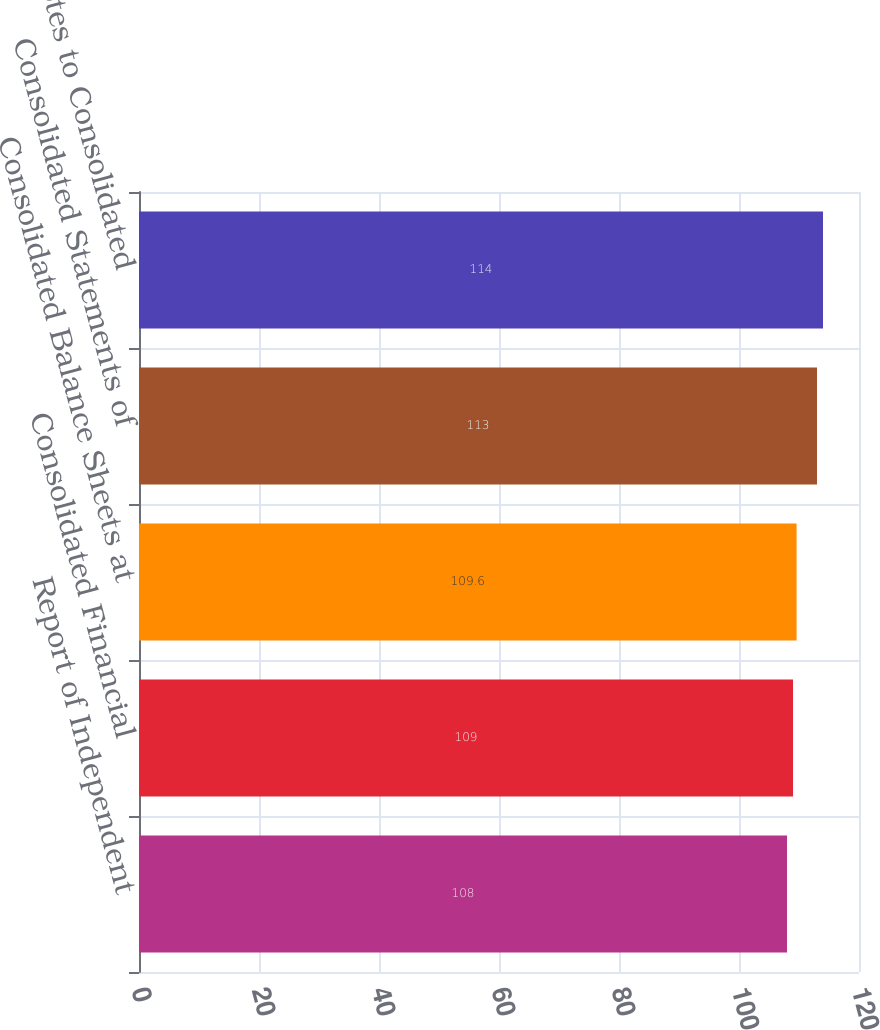<chart> <loc_0><loc_0><loc_500><loc_500><bar_chart><fcel>Report of Independent<fcel>Consolidated Financial<fcel>Consolidated Balance Sheets at<fcel>Consolidated Statements of<fcel>Notes to Consolidated<nl><fcel>108<fcel>109<fcel>109.6<fcel>113<fcel>114<nl></chart> 